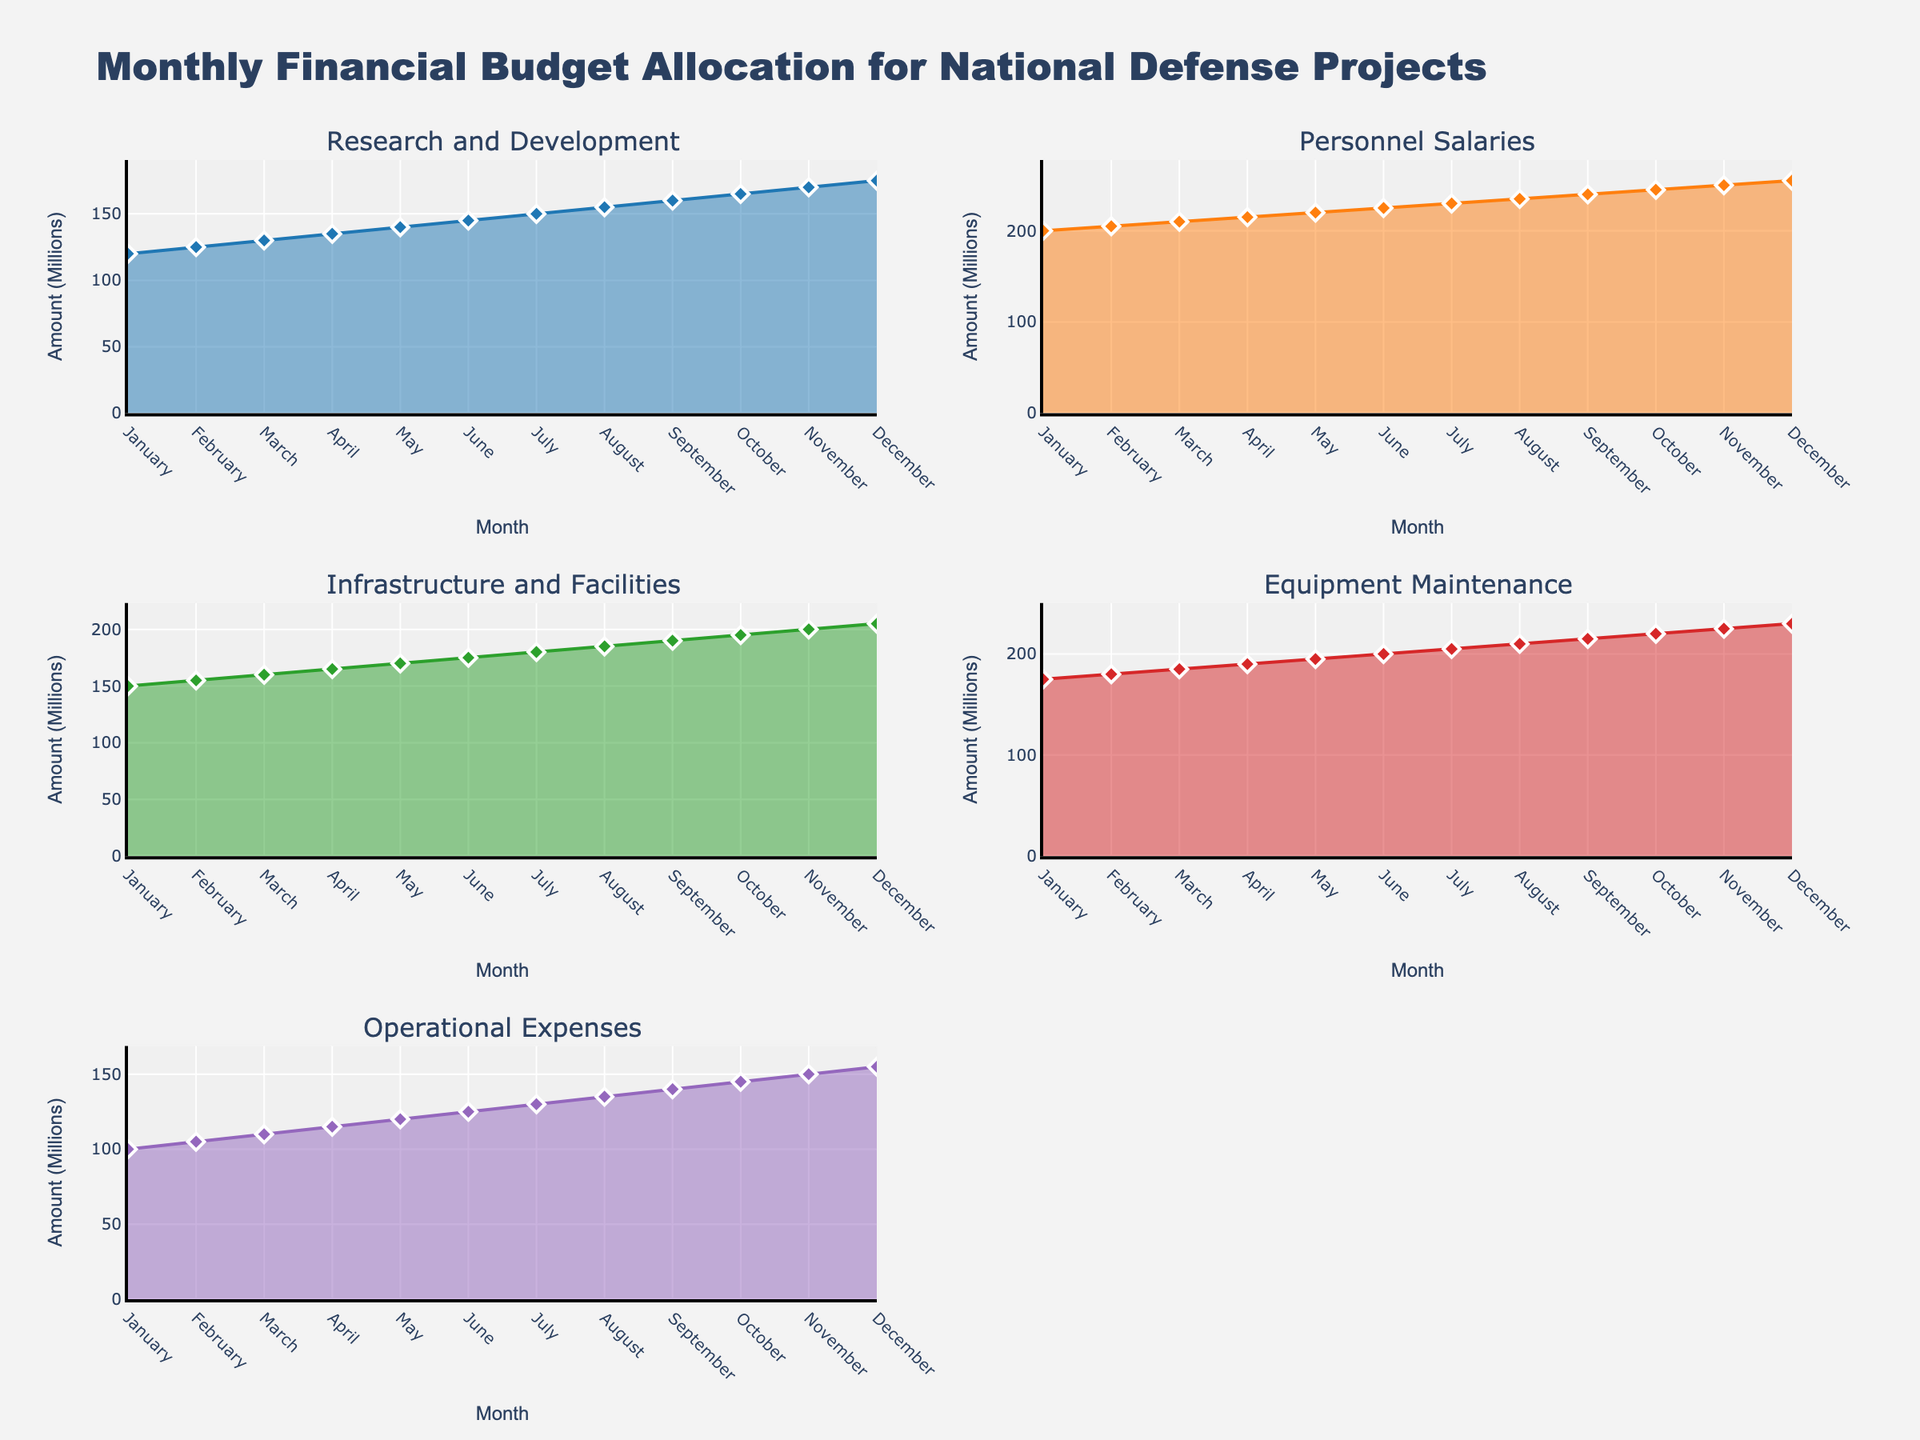What is the total budget for Equipment Maintenance in June? The subplot for Equipment Maintenance shows a single data point for each month. For June, the budget is listed as 200 million.
Answer: 200M What is the highest budget allocated for Personnel Salaries throughout the year? We observe the subplot for Personnel Salaries across all months, looking for the highest value. In December, it reaches 255 million.
Answer: 255M Which category had the smallest budget in January? Checking the January data point for each category, Operational Expenses has the smallest allocation at 100 million.
Answer: Operational Expenses How did the budget for Research and Development change from January to June? January's budget was 120 million, and by June, it increased to 145 million. So, the budget increased by 25 million.
Answer: Increased by 25M Compare the budget for Infrastructure and Facilities between March and September. The subplot for Infrastructure and Facilities shows 160 million in March and 190 million in September. The budget increased by 30 million.
Answer: Increased by 30M What is the average monthly budget for Operational Expenses from January to December? Summing all the monthly budgets for Operational Expenses (100M, 105M, 110M, 115M, 120M, 125M, 130M, 135M, 140M, 145M, 150M, 155M) gives 1530 million. Dividing by 12 months gives an average of 127.5 million.
Answer: 127.5M By how much did the budget for Research and Development increase from January to December? The Research and Development budget rises from 120 million in January to 175 million in December. The increase is 55 million.
Answer: 55M Which category experienced the most consistent budget growth over the months? Examining the subplots, Personnel Salaries show a consistent increment each month without any dips.
Answer: Personnel Salaries During which month did Equipment Maintenance see the highest budget increase from the previous month? Observing the month-to-month changes, the biggest increase is from June (200 million) to July (205 million), an increase of 5 million.
Answer: June to July 